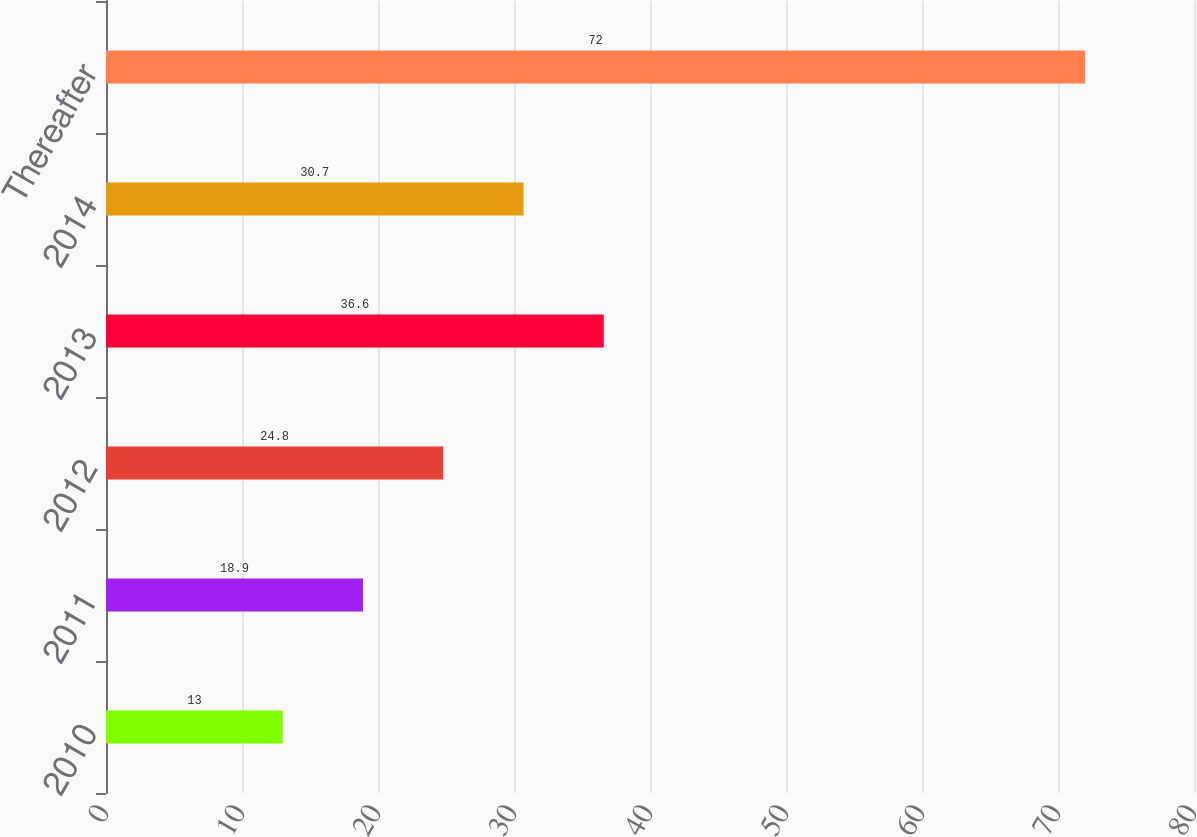Convert chart to OTSL. <chart><loc_0><loc_0><loc_500><loc_500><bar_chart><fcel>2010<fcel>2011<fcel>2012<fcel>2013<fcel>2014<fcel>Thereafter<nl><fcel>13<fcel>18.9<fcel>24.8<fcel>36.6<fcel>30.7<fcel>72<nl></chart> 